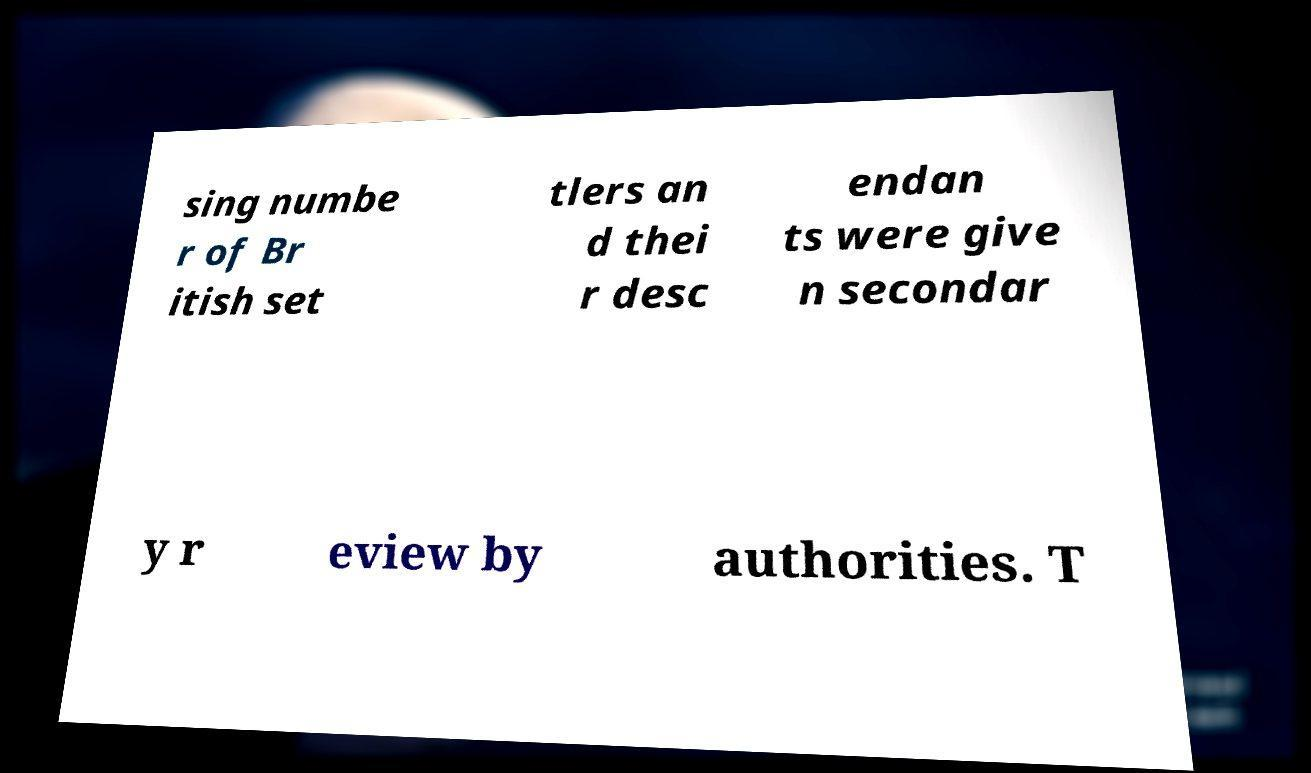Could you assist in decoding the text presented in this image and type it out clearly? sing numbe r of Br itish set tlers an d thei r desc endan ts were give n secondar y r eview by authorities. T 